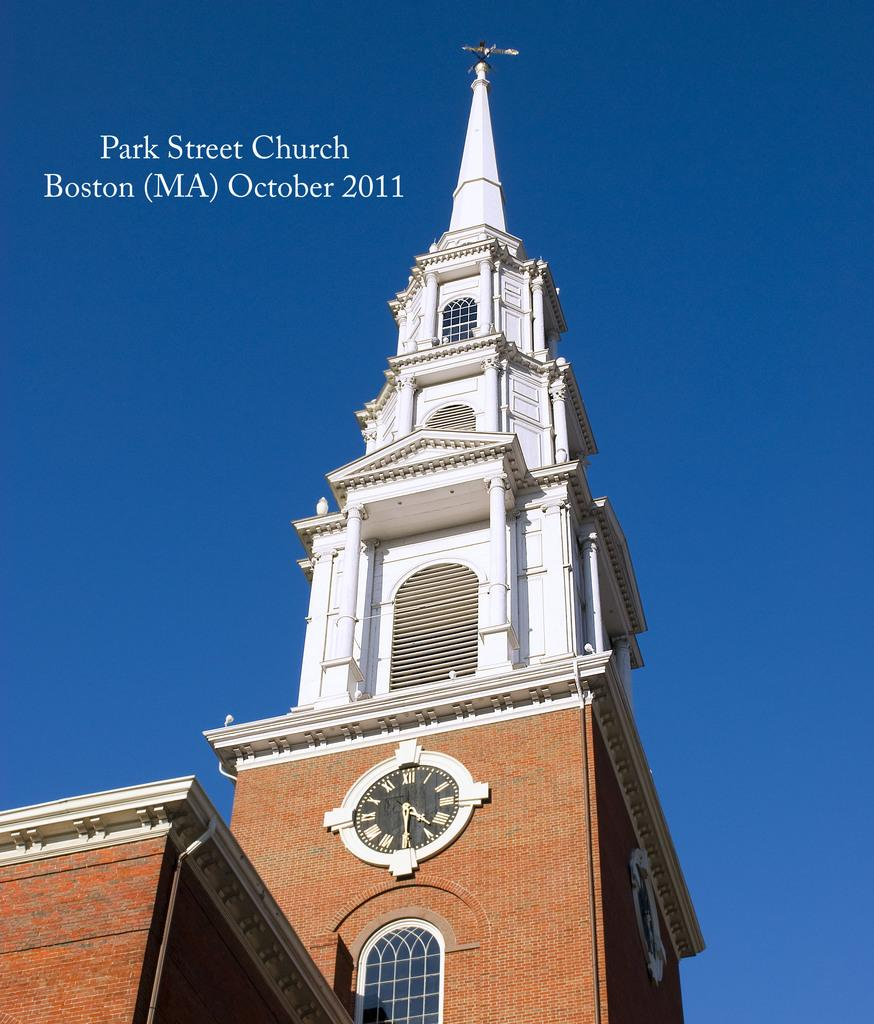<image>
Summarize the visual content of the image. The historic Park Street Church steeple in Boston. 